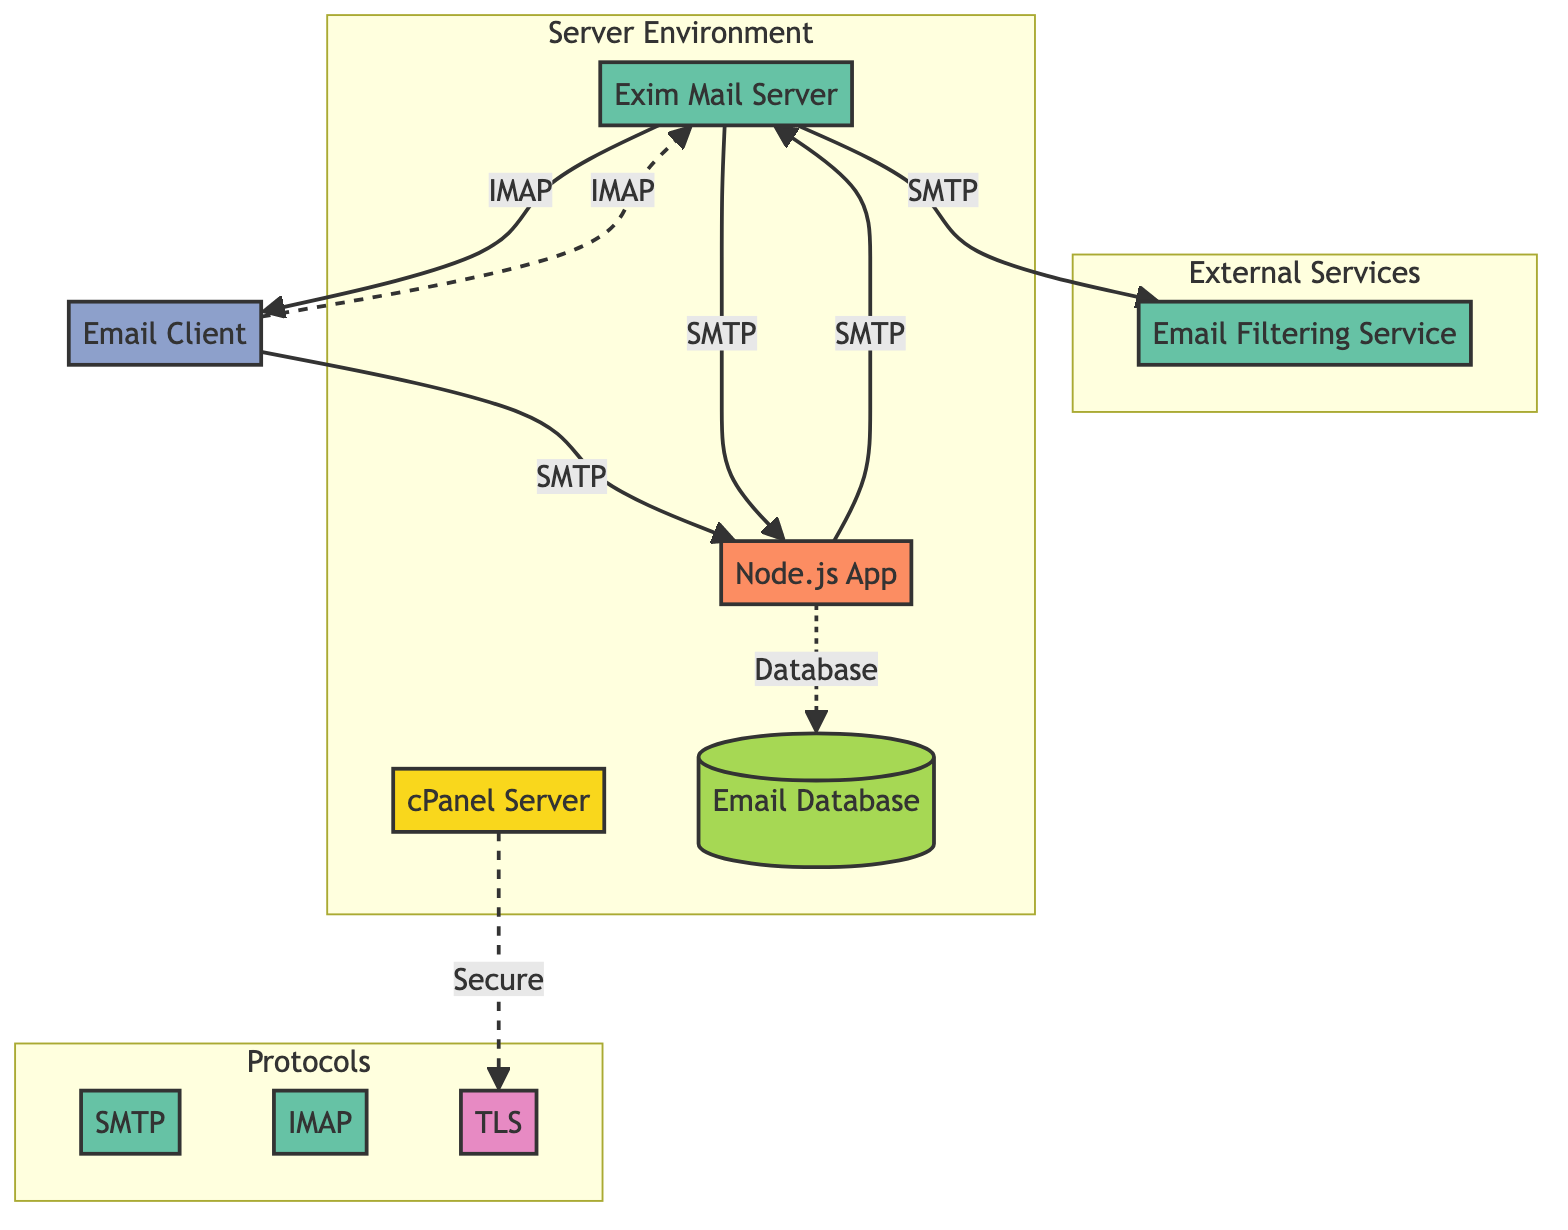What is the main server hosting the email management? The diagram specifies that the "cPanel Server" is the central host for email management, indicated as the first node and labeled accordingly.
Answer: cPanel Server How many client nodes are present in the diagram? The diagram shows one node labeled as "Email Client," indicating that there is a total of one client in the diagram.
Answer: 1 Which service handles sending and receiving emails? The "Exim Mail Server" is defined in the diagram as the service responsible for sending and receiving emails, connecting to various other nodes.
Answer: Exim Mail Server What protocol is used for retrieving email messages? The diagram identifies "IMAP" as the protocol for retrieving emails, distinguished clearly among other protocol services.
Answer: IMAP From which node does the Node.js application send emails? The diagram indicates that the "Node.js App" sends emails to the "Exim Mail Server," as shown by the directed edge connecting these two nodes via SMTP.
Answer: Exim Mail Server How does secure communication occur within the network? The diagram outlines that the "cPanel Server" uses "TLS" for secure communication in all email transmissions, showing a connection that emphasizes its security role.
Answer: TLS What is the purpose of the Email Database? The diagram describes the "Email Database" managed by the Node.js application as a place for storing email metadata and transactional information, emphasizing its role in auditing and history.
Answer: Store email metadata What is the relationship between the Exim Mail Server and the Email Filtering Service? The diagram shows that the "Exim Mail Server" sends emails to the "Email Filtering Service," indicating a processing step in the email flow before delivery to the recipient.
Answer: Sending email outbound Which service is used for sending email messages? The diagram features "SMTP" as the protocol/service specifically used for sending email messages, indicated prominently among other services and protocols.
Answer: SMTP 